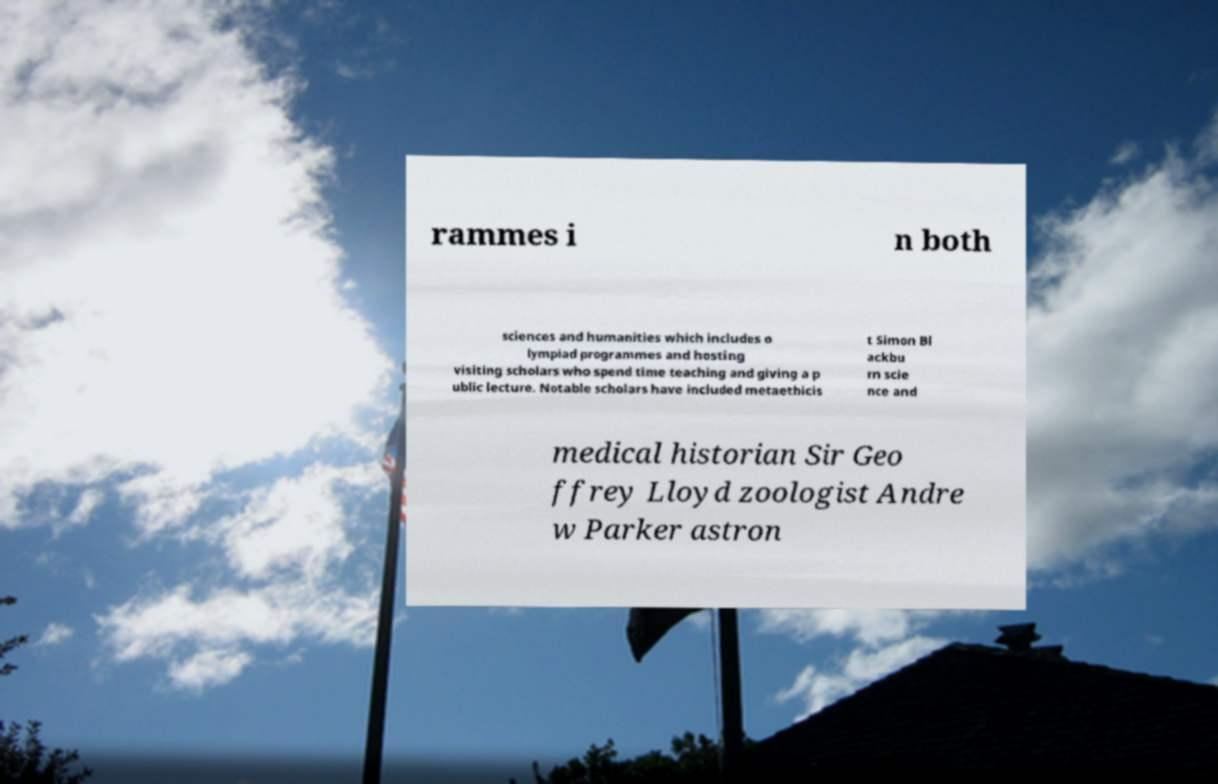There's text embedded in this image that I need extracted. Can you transcribe it verbatim? rammes i n both sciences and humanities which includes o lympiad programmes and hosting visiting scholars who spend time teaching and giving a p ublic lecture. Notable scholars have included metaethicis t Simon Bl ackbu rn scie nce and medical historian Sir Geo ffrey Lloyd zoologist Andre w Parker astron 